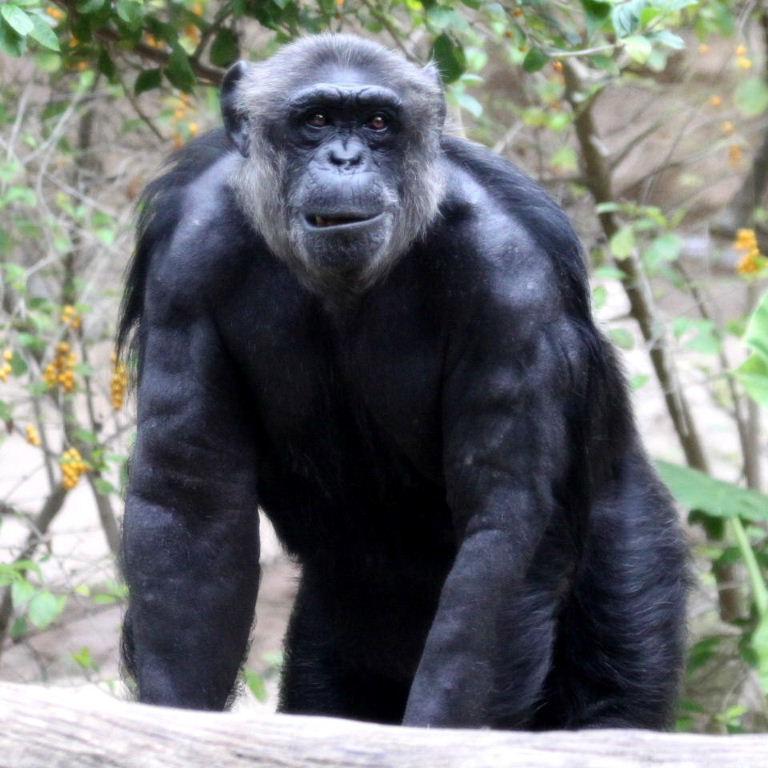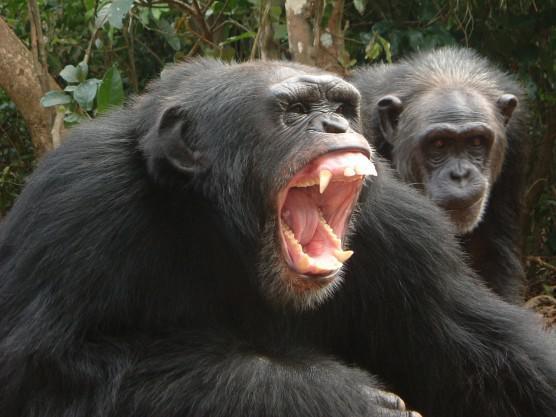The first image is the image on the left, the second image is the image on the right. For the images displayed, is the sentence "The animal in the image on the left has both arms resting on its knees." factually correct? Answer yes or no. No. 